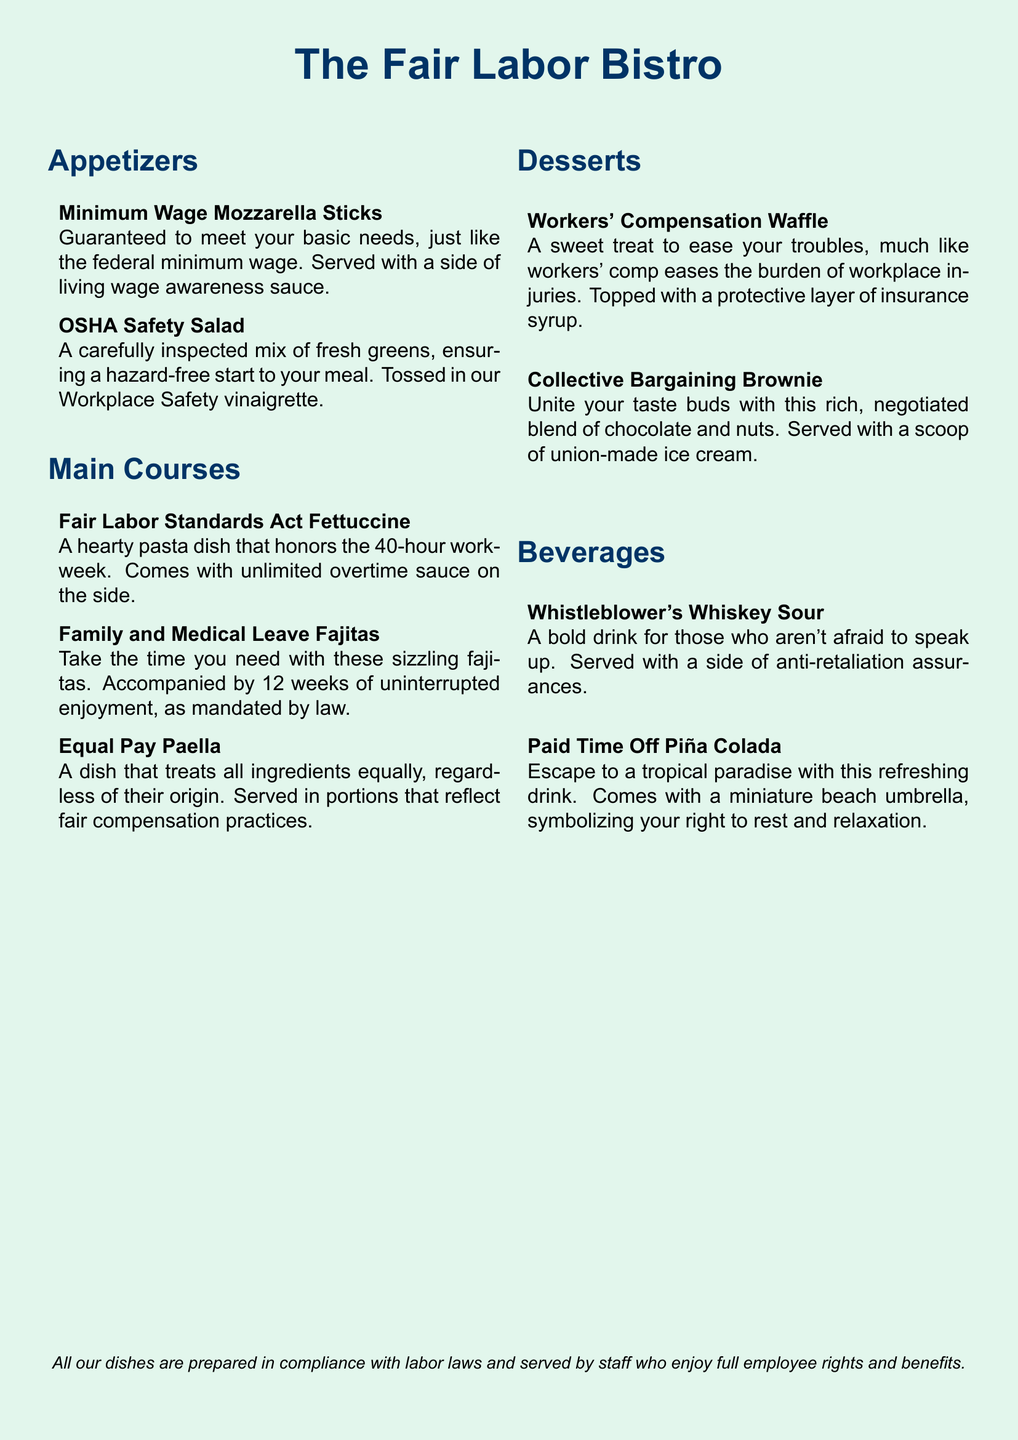What is the name of the restaurant? The restaurant's name appears at the top of the menu, prominently displayed in large font.
Answer: The Fair Labor Bistro What dish is served with a living wage awareness sauce? The dish description mentions a sauce that highlights living wage awareness.
Answer: Minimum Wage Mozzarella Sticks How many weeks of enjoyment are provided with the Family and Medical Leave Fajitas? The dish's description states the number of weeks of uninterrupted enjoyment according to the law.
Answer: 12 weeks What dessert is associated with easing troubles of workplace injuries? The description talks about a treat that is similar in function to workers' compensation, specifically mentioning its purpose.
Answer: Workers' Compensation Waffle Which beverage symbolizes the right to rest and relaxation? The drink's description indicates it comes with an item that represents rest and relaxation rights.
Answer: Paid Time Off Piña Colada What is a key ingredient in the Collective Bargaining Brownie? The description emphasizes a specific ingredient that enhances the flavor and richness of the dessert, illustrating its collaborative nature.
Answer: Chocolate What type of salad is mentioned in the appetizers? The menu lists a salad that references safety and health regulations in the workplace.
Answer: OSHA Safety Salad What type of drink is served with anti-retaliation assurances? The beverage description highlights the theme of speaking up and the assurances that accompany it.
Answer: Whistleblower's Whiskey Sour What main course honors the 40-hour workweek? The dish's name reflects a significant labor law regarding work hours.
Answer: Fair Labor Standards Act Fettuccine 